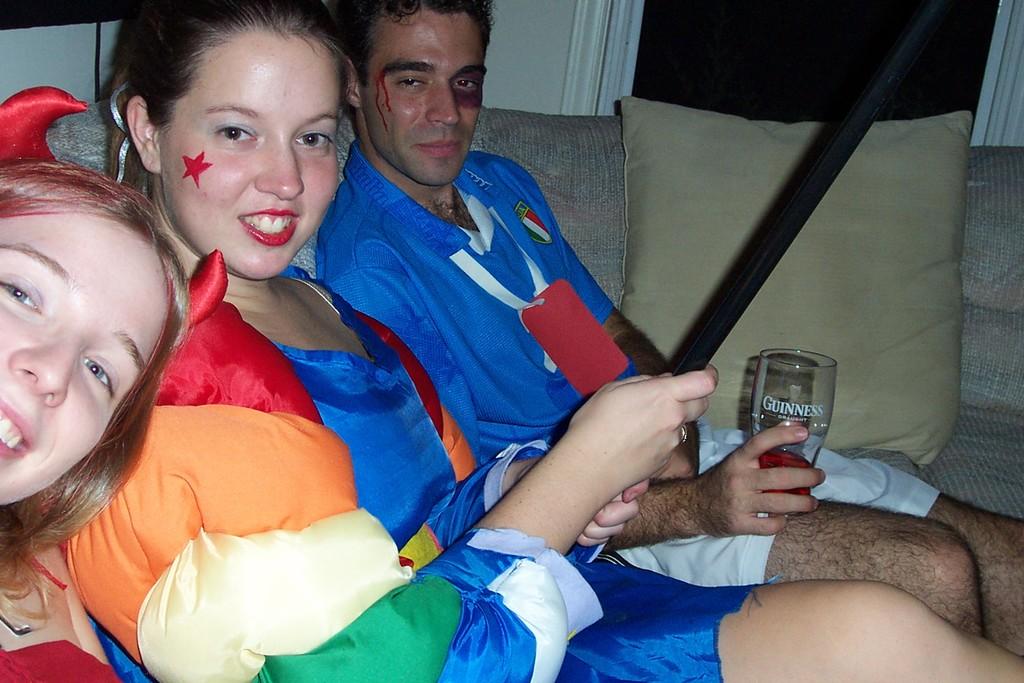What is he drinking?
Keep it short and to the point. Guinness. Does that glass say guinness?
Ensure brevity in your answer.  Yes. 